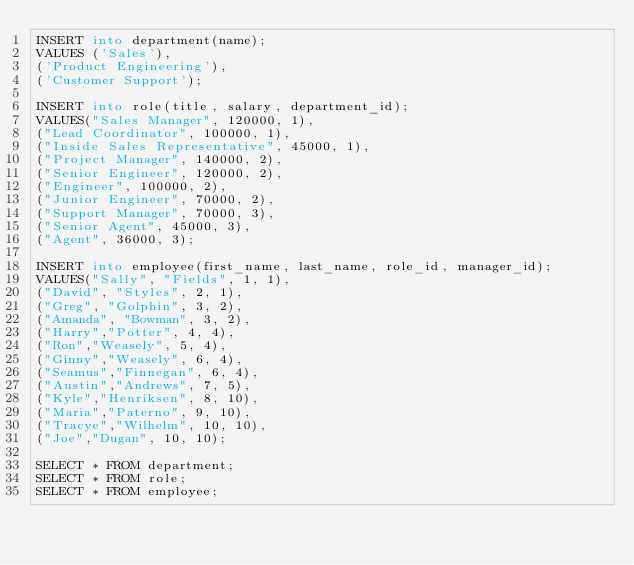Convert code to text. <code><loc_0><loc_0><loc_500><loc_500><_SQL_>INSERT into department(name);
VALUES ('Sales'),
('Product Engineering'),
('Customer Support');

INSERT into role(title, salary, department_id);
VALUES("Sales Manager", 120000, 1),
("Lead Coordinator", 100000, 1),
("Inside Sales Representative", 45000, 1),
("Project Manager", 140000, 2),
("Senior Engineer", 120000, 2),
("Engineer", 100000, 2),
("Junior Engineer", 70000, 2),
("Support Manager", 70000, 3),
("Senior Agent", 45000, 3),
("Agent", 36000, 3);

INSERT into employee(first_name, last_name, role_id, manager_id);
VALUES("Sally", "Fields", 1, 1),
("David", "Styles", 2, 1),
("Greg", "Golphin", 3, 2),
("Amanda", "Bowman", 3, 2),
("Harry","Potter", 4, 4),
("Ron","Weasely", 5, 4),
("Ginny","Weasely", 6, 4),
("Seamus","Finnegan", 6, 4),
("Austin","Andrews", 7, 5),
("Kyle","Henriksen", 8, 10),
("Maria","Paterno", 9, 10),
("Tracye","Wilhelm", 10, 10),
("Joe","Dugan", 10, 10);

SELECT * FROM department;
SELECT * FROM role;
SELECT * FROM employee;
</code> 